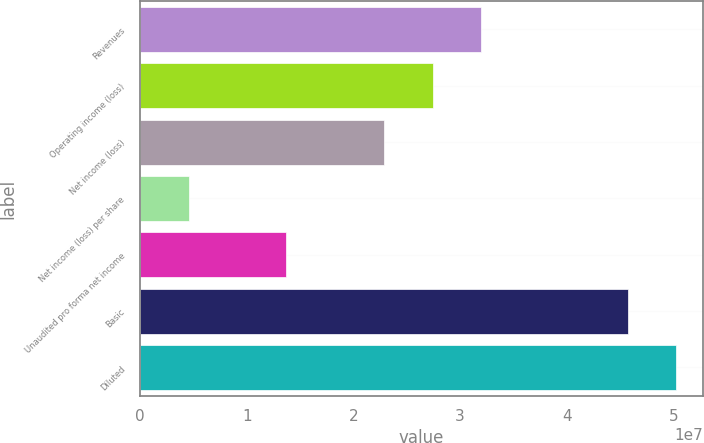Convert chart. <chart><loc_0><loc_0><loc_500><loc_500><bar_chart><fcel>Revenues<fcel>Operating income (loss)<fcel>Net income (loss)<fcel>Net income (loss) per share<fcel>Unaudited pro forma net income<fcel>Basic<fcel>Diluted<nl><fcel>3.19955e+07<fcel>2.74247e+07<fcel>2.28539e+07<fcel>4.57078e+06<fcel>1.37123e+07<fcel>4.57078e+07<fcel>5.02786e+07<nl></chart> 